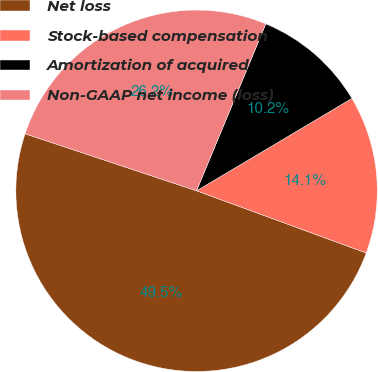Convert chart to OTSL. <chart><loc_0><loc_0><loc_500><loc_500><pie_chart><fcel>Net loss<fcel>Stock-based compensation<fcel>Amortization of acquired<fcel>Non-GAAP net income (loss)<nl><fcel>49.51%<fcel>14.13%<fcel>10.2%<fcel>26.15%<nl></chart> 